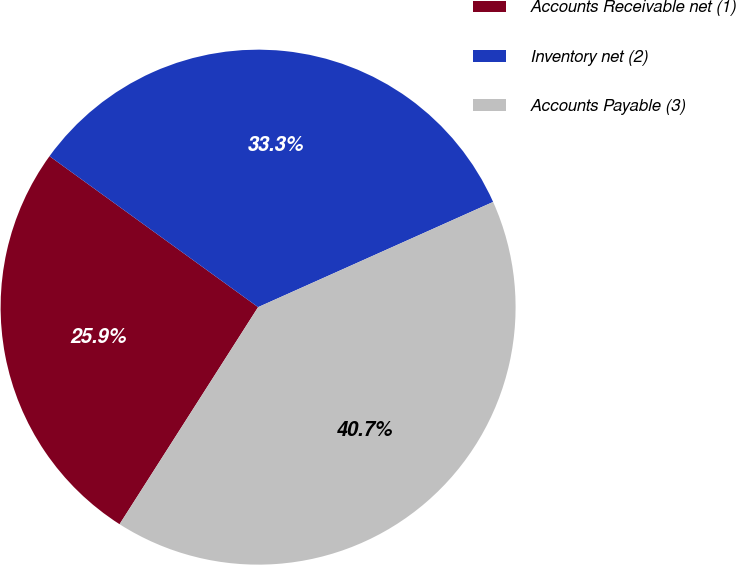Convert chart. <chart><loc_0><loc_0><loc_500><loc_500><pie_chart><fcel>Accounts Receivable net (1)<fcel>Inventory net (2)<fcel>Accounts Payable (3)<nl><fcel>25.93%<fcel>33.33%<fcel>40.74%<nl></chart> 